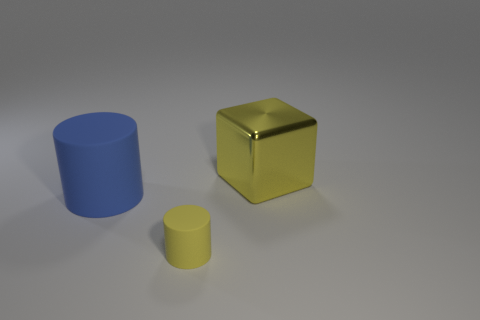Is there any other thing that is made of the same material as the yellow cube?
Keep it short and to the point. No. What number of big metal objects have the same color as the small matte cylinder?
Ensure brevity in your answer.  1. Are there more small matte cylinders than tiny cyan spheres?
Give a very brief answer. Yes. What is the size of the thing that is to the right of the blue rubber thing and in front of the yellow metallic thing?
Your answer should be compact. Small. Does the cylinder to the right of the big blue rubber thing have the same material as the large object that is on the left side of the large block?
Offer a terse response. Yes. The blue thing that is the same size as the yellow block is what shape?
Ensure brevity in your answer.  Cylinder. Are there fewer blue rubber spheres than small matte objects?
Make the answer very short. Yes. Is there a big yellow block that is to the right of the large object on the right side of the tiny yellow thing?
Offer a terse response. No. There is a matte cylinder that is on the right side of the big thing left of the tiny thing; are there any small cylinders left of it?
Give a very brief answer. No. Is the shape of the matte thing that is left of the yellow cylinder the same as the yellow thing to the right of the small yellow rubber thing?
Your response must be concise. No. 